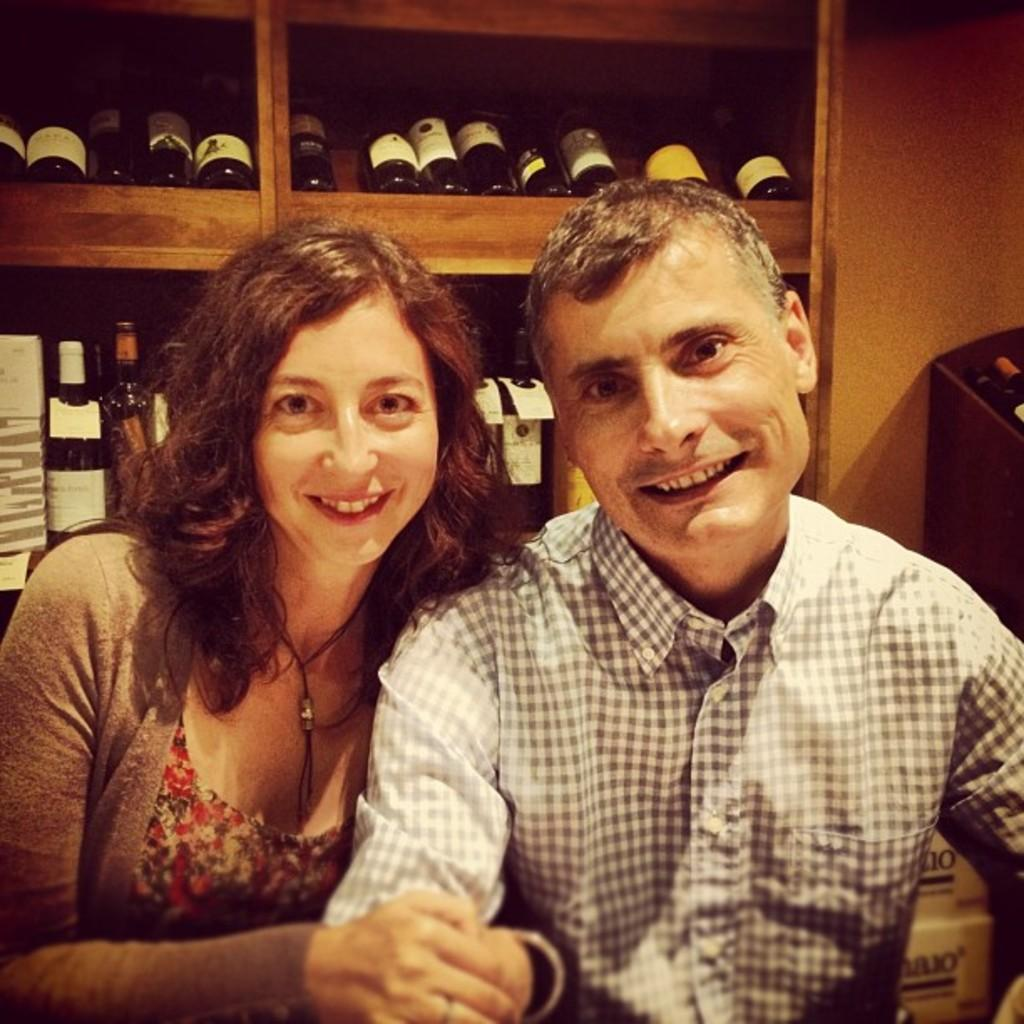Who is present in the image? There is a woman and a man in the image. What are the expressions on their faces? Both the woman and the man are smiling. What can be seen in the background of the image? There are many bottles arranged in a rack in the background. What is located beside the rock in the image? There are objects beside the rock in the image. What type of tree can be seen growing beside the rock in the image? There is no tree visible beside the rock in the image. How are the people in the image using the objects beside the rock? The image does not show the people using any objects; they are simply smiling. 